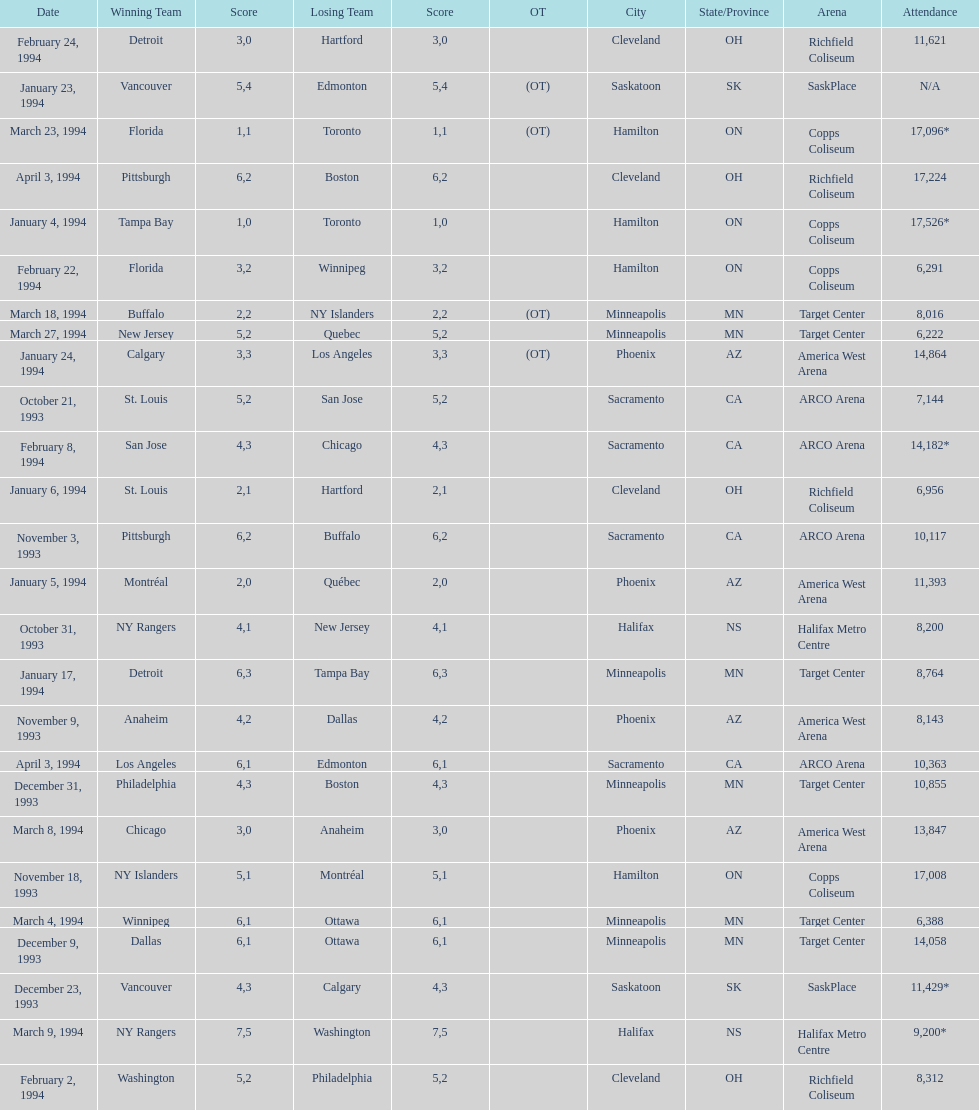How many events occurred in minneapolis, mn? 6. 